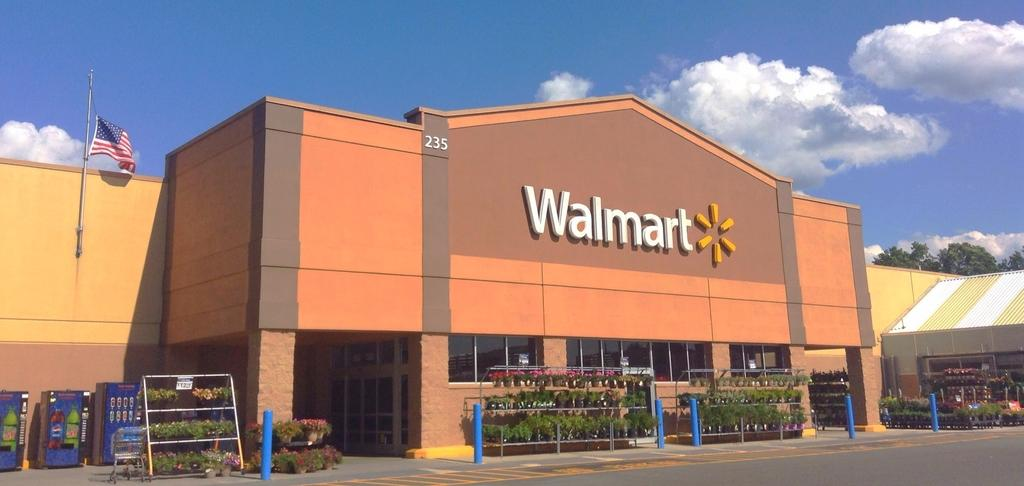What types of living organisms can be seen in the image? Plants and flowers are visible in the image. What man-made objects can be seen in the image? Machines, a cart, a flag, a shade, a building, and a road can be seen in the image. What is the natural setting visible in the image? Trees are visible in the image. What is visible in the background of the image? The sky is visible in the background of the image. What can be seen in the sky? Clouds can be seen in the sky. What type of song is being played by the oranges in the image? There are no oranges present in the image, and therefore no such activity can be observed. How many legs can be seen on the plants in the image? Plants do not have legs, so this question cannot be answered based on the information provided. 